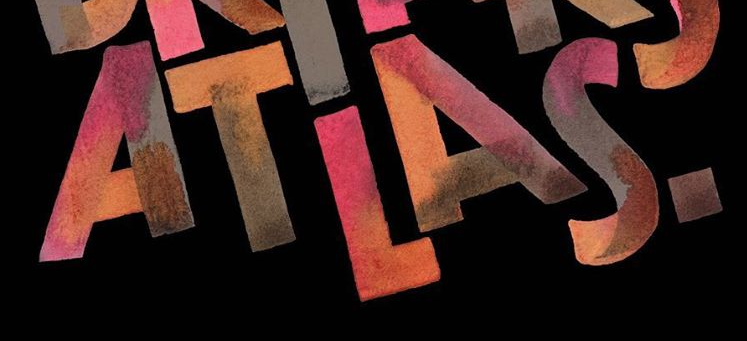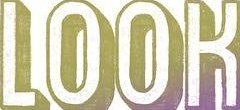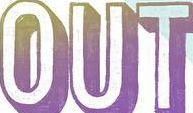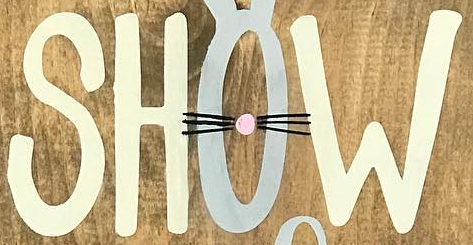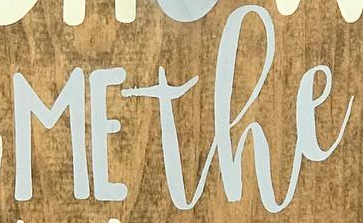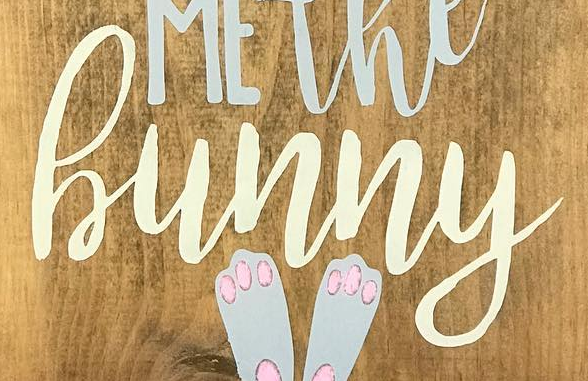What text is displayed in these images sequentially, separated by a semicolon? ATLAS.; LOOK; OUT; SHOW; MEthe; hunny 